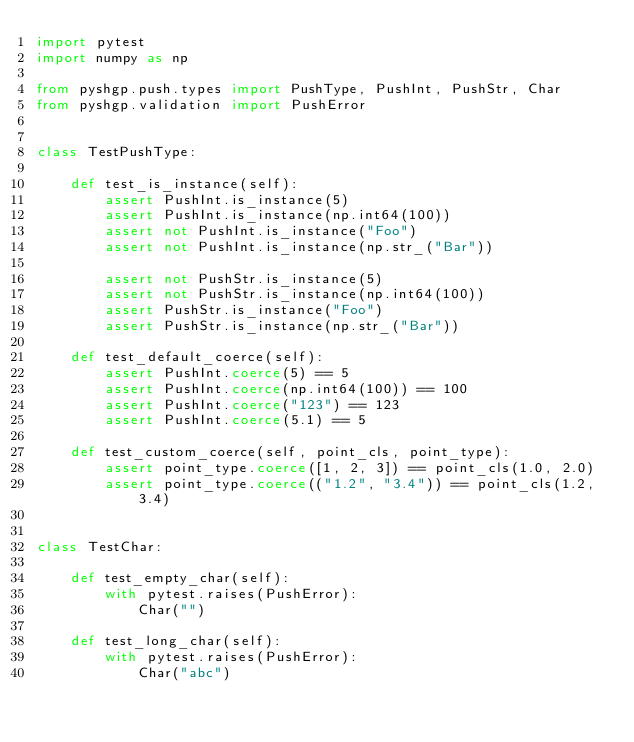<code> <loc_0><loc_0><loc_500><loc_500><_Python_>import pytest
import numpy as np

from pyshgp.push.types import PushType, PushInt, PushStr, Char
from pyshgp.validation import PushError


class TestPushType:

    def test_is_instance(self):
        assert PushInt.is_instance(5)
        assert PushInt.is_instance(np.int64(100))
        assert not PushInt.is_instance("Foo")
        assert not PushInt.is_instance(np.str_("Bar"))

        assert not PushStr.is_instance(5)
        assert not PushStr.is_instance(np.int64(100))
        assert PushStr.is_instance("Foo")
        assert PushStr.is_instance(np.str_("Bar"))

    def test_default_coerce(self):
        assert PushInt.coerce(5) == 5
        assert PushInt.coerce(np.int64(100)) == 100
        assert PushInt.coerce("123") == 123
        assert PushInt.coerce(5.1) == 5

    def test_custom_coerce(self, point_cls, point_type):
        assert point_type.coerce([1, 2, 3]) == point_cls(1.0, 2.0)
        assert point_type.coerce(("1.2", "3.4")) == point_cls(1.2, 3.4)


class TestChar:

    def test_empty_char(self):
        with pytest.raises(PushError):
            Char("")

    def test_long_char(self):
        with pytest.raises(PushError):
            Char("abc")
</code> 